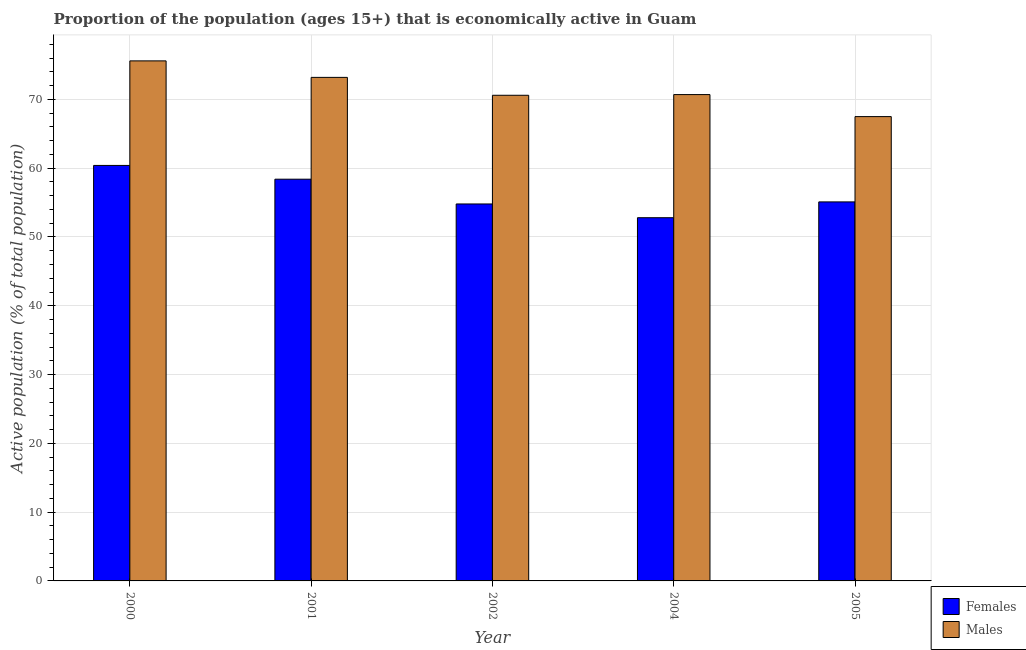Are the number of bars per tick equal to the number of legend labels?
Your answer should be compact. Yes. Are the number of bars on each tick of the X-axis equal?
Your answer should be compact. Yes. How many bars are there on the 5th tick from the right?
Keep it short and to the point. 2. What is the percentage of economically active male population in 2004?
Your response must be concise. 70.7. Across all years, what is the maximum percentage of economically active male population?
Make the answer very short. 75.6. Across all years, what is the minimum percentage of economically active male population?
Offer a very short reply. 67.5. In which year was the percentage of economically active male population maximum?
Your response must be concise. 2000. In which year was the percentage of economically active female population minimum?
Provide a succinct answer. 2004. What is the total percentage of economically active male population in the graph?
Your answer should be very brief. 357.6. What is the difference between the percentage of economically active male population in 2004 and that in 2005?
Make the answer very short. 3.2. What is the difference between the percentage of economically active male population in 2005 and the percentage of economically active female population in 2002?
Give a very brief answer. -3.1. What is the average percentage of economically active male population per year?
Give a very brief answer. 71.52. In the year 2001, what is the difference between the percentage of economically active female population and percentage of economically active male population?
Your answer should be compact. 0. In how many years, is the percentage of economically active female population greater than 16 %?
Provide a short and direct response. 5. What is the ratio of the percentage of economically active male population in 2000 to that in 2001?
Give a very brief answer. 1.03. Is the percentage of economically active female population in 2000 less than that in 2001?
Provide a short and direct response. No. What is the difference between the highest and the second highest percentage of economically active male population?
Offer a very short reply. 2.4. What is the difference between the highest and the lowest percentage of economically active male population?
Your response must be concise. 8.1. Is the sum of the percentage of economically active male population in 2000 and 2002 greater than the maximum percentage of economically active female population across all years?
Provide a succinct answer. Yes. What does the 1st bar from the left in 2002 represents?
Offer a terse response. Females. What does the 2nd bar from the right in 2002 represents?
Offer a very short reply. Females. What is the difference between two consecutive major ticks on the Y-axis?
Keep it short and to the point. 10. Does the graph contain grids?
Your response must be concise. Yes. Where does the legend appear in the graph?
Ensure brevity in your answer.  Bottom right. How many legend labels are there?
Your answer should be compact. 2. How are the legend labels stacked?
Make the answer very short. Vertical. What is the title of the graph?
Give a very brief answer. Proportion of the population (ages 15+) that is economically active in Guam. Does "Nitrous oxide emissions" appear as one of the legend labels in the graph?
Your answer should be compact. No. What is the label or title of the X-axis?
Your answer should be compact. Year. What is the label or title of the Y-axis?
Your response must be concise. Active population (% of total population). What is the Active population (% of total population) of Females in 2000?
Provide a short and direct response. 60.4. What is the Active population (% of total population) in Males in 2000?
Make the answer very short. 75.6. What is the Active population (% of total population) of Females in 2001?
Ensure brevity in your answer.  58.4. What is the Active population (% of total population) in Males in 2001?
Ensure brevity in your answer.  73.2. What is the Active population (% of total population) in Females in 2002?
Keep it short and to the point. 54.8. What is the Active population (% of total population) of Males in 2002?
Ensure brevity in your answer.  70.6. What is the Active population (% of total population) of Females in 2004?
Your answer should be very brief. 52.8. What is the Active population (% of total population) in Males in 2004?
Keep it short and to the point. 70.7. What is the Active population (% of total population) in Females in 2005?
Provide a short and direct response. 55.1. What is the Active population (% of total population) in Males in 2005?
Ensure brevity in your answer.  67.5. Across all years, what is the maximum Active population (% of total population) in Females?
Your answer should be compact. 60.4. Across all years, what is the maximum Active population (% of total population) of Males?
Keep it short and to the point. 75.6. Across all years, what is the minimum Active population (% of total population) of Females?
Your answer should be very brief. 52.8. Across all years, what is the minimum Active population (% of total population) of Males?
Offer a very short reply. 67.5. What is the total Active population (% of total population) of Females in the graph?
Your response must be concise. 281.5. What is the total Active population (% of total population) of Males in the graph?
Your answer should be compact. 357.6. What is the difference between the Active population (% of total population) in Males in 2000 and that in 2001?
Make the answer very short. 2.4. What is the difference between the Active population (% of total population) of Females in 2000 and that in 2004?
Your answer should be compact. 7.6. What is the difference between the Active population (% of total population) in Females in 2001 and that in 2002?
Offer a terse response. 3.6. What is the difference between the Active population (% of total population) of Males in 2001 and that in 2005?
Your answer should be compact. 5.7. What is the difference between the Active population (% of total population) of Females in 2002 and that in 2004?
Make the answer very short. 2. What is the difference between the Active population (% of total population) in Females in 2002 and that in 2005?
Offer a terse response. -0.3. What is the difference between the Active population (% of total population) in Females in 2004 and that in 2005?
Ensure brevity in your answer.  -2.3. What is the difference between the Active population (% of total population) of Males in 2004 and that in 2005?
Give a very brief answer. 3.2. What is the difference between the Active population (% of total population) in Females in 2000 and the Active population (% of total population) in Males in 2004?
Your response must be concise. -10.3. What is the difference between the Active population (% of total population) of Females in 2000 and the Active population (% of total population) of Males in 2005?
Make the answer very short. -7.1. What is the difference between the Active population (% of total population) in Females in 2001 and the Active population (% of total population) in Males in 2002?
Offer a very short reply. -12.2. What is the difference between the Active population (% of total population) in Females in 2002 and the Active population (% of total population) in Males in 2004?
Your answer should be very brief. -15.9. What is the difference between the Active population (% of total population) of Females in 2002 and the Active population (% of total population) of Males in 2005?
Ensure brevity in your answer.  -12.7. What is the difference between the Active population (% of total population) in Females in 2004 and the Active population (% of total population) in Males in 2005?
Give a very brief answer. -14.7. What is the average Active population (% of total population) in Females per year?
Offer a very short reply. 56.3. What is the average Active population (% of total population) of Males per year?
Give a very brief answer. 71.52. In the year 2000, what is the difference between the Active population (% of total population) of Females and Active population (% of total population) of Males?
Your answer should be compact. -15.2. In the year 2001, what is the difference between the Active population (% of total population) in Females and Active population (% of total population) in Males?
Offer a terse response. -14.8. In the year 2002, what is the difference between the Active population (% of total population) of Females and Active population (% of total population) of Males?
Your answer should be compact. -15.8. In the year 2004, what is the difference between the Active population (% of total population) in Females and Active population (% of total population) in Males?
Give a very brief answer. -17.9. In the year 2005, what is the difference between the Active population (% of total population) in Females and Active population (% of total population) in Males?
Offer a very short reply. -12.4. What is the ratio of the Active population (% of total population) in Females in 2000 to that in 2001?
Your response must be concise. 1.03. What is the ratio of the Active population (% of total population) of Males in 2000 to that in 2001?
Your answer should be compact. 1.03. What is the ratio of the Active population (% of total population) of Females in 2000 to that in 2002?
Your response must be concise. 1.1. What is the ratio of the Active population (% of total population) in Males in 2000 to that in 2002?
Give a very brief answer. 1.07. What is the ratio of the Active population (% of total population) in Females in 2000 to that in 2004?
Offer a terse response. 1.14. What is the ratio of the Active population (% of total population) in Males in 2000 to that in 2004?
Offer a terse response. 1.07. What is the ratio of the Active population (% of total population) of Females in 2000 to that in 2005?
Provide a succinct answer. 1.1. What is the ratio of the Active population (% of total population) of Males in 2000 to that in 2005?
Ensure brevity in your answer.  1.12. What is the ratio of the Active population (% of total population) of Females in 2001 to that in 2002?
Give a very brief answer. 1.07. What is the ratio of the Active population (% of total population) in Males in 2001 to that in 2002?
Provide a short and direct response. 1.04. What is the ratio of the Active population (% of total population) of Females in 2001 to that in 2004?
Ensure brevity in your answer.  1.11. What is the ratio of the Active population (% of total population) of Males in 2001 to that in 2004?
Keep it short and to the point. 1.04. What is the ratio of the Active population (% of total population) of Females in 2001 to that in 2005?
Your response must be concise. 1.06. What is the ratio of the Active population (% of total population) in Males in 2001 to that in 2005?
Your response must be concise. 1.08. What is the ratio of the Active population (% of total population) of Females in 2002 to that in 2004?
Provide a short and direct response. 1.04. What is the ratio of the Active population (% of total population) in Females in 2002 to that in 2005?
Keep it short and to the point. 0.99. What is the ratio of the Active population (% of total population) in Males in 2002 to that in 2005?
Your response must be concise. 1.05. What is the ratio of the Active population (% of total population) in Females in 2004 to that in 2005?
Ensure brevity in your answer.  0.96. What is the ratio of the Active population (% of total population) of Males in 2004 to that in 2005?
Offer a very short reply. 1.05. What is the difference between the highest and the second highest Active population (% of total population) of Males?
Ensure brevity in your answer.  2.4. What is the difference between the highest and the lowest Active population (% of total population) in Females?
Provide a short and direct response. 7.6. What is the difference between the highest and the lowest Active population (% of total population) in Males?
Your response must be concise. 8.1. 